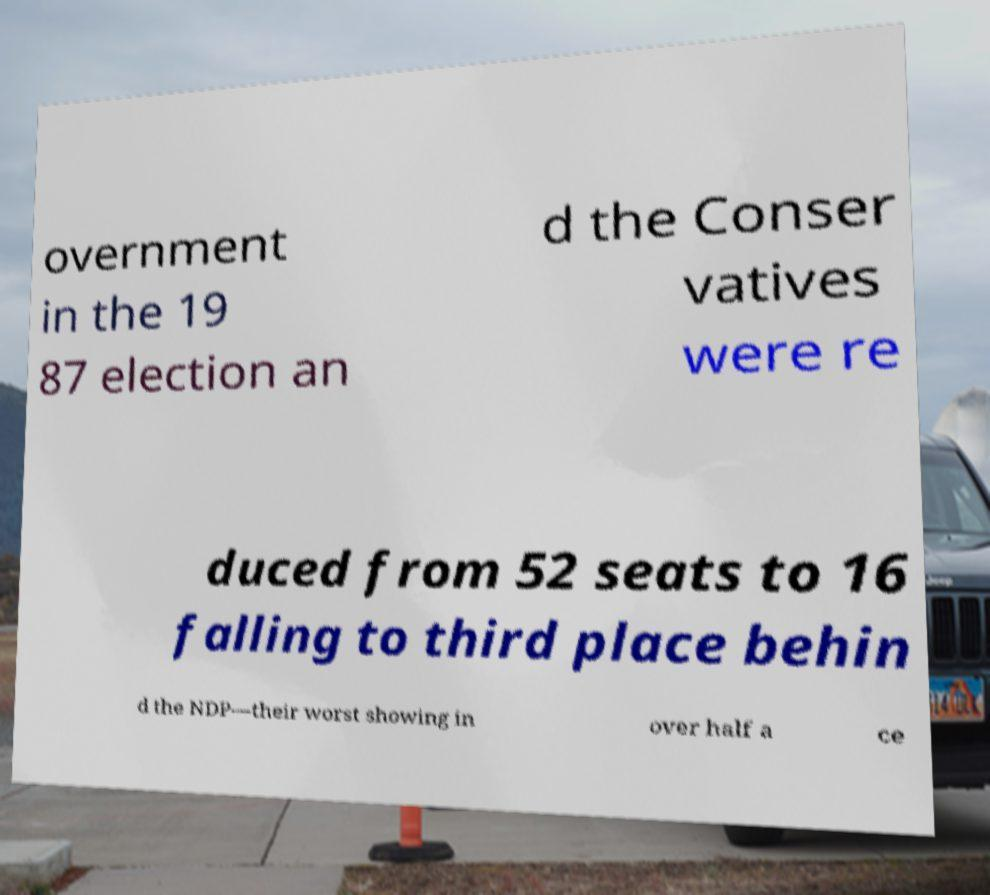Can you read and provide the text displayed in the image?This photo seems to have some interesting text. Can you extract and type it out for me? overnment in the 19 87 election an d the Conser vatives were re duced from 52 seats to 16 falling to third place behin d the NDP—their worst showing in over half a ce 